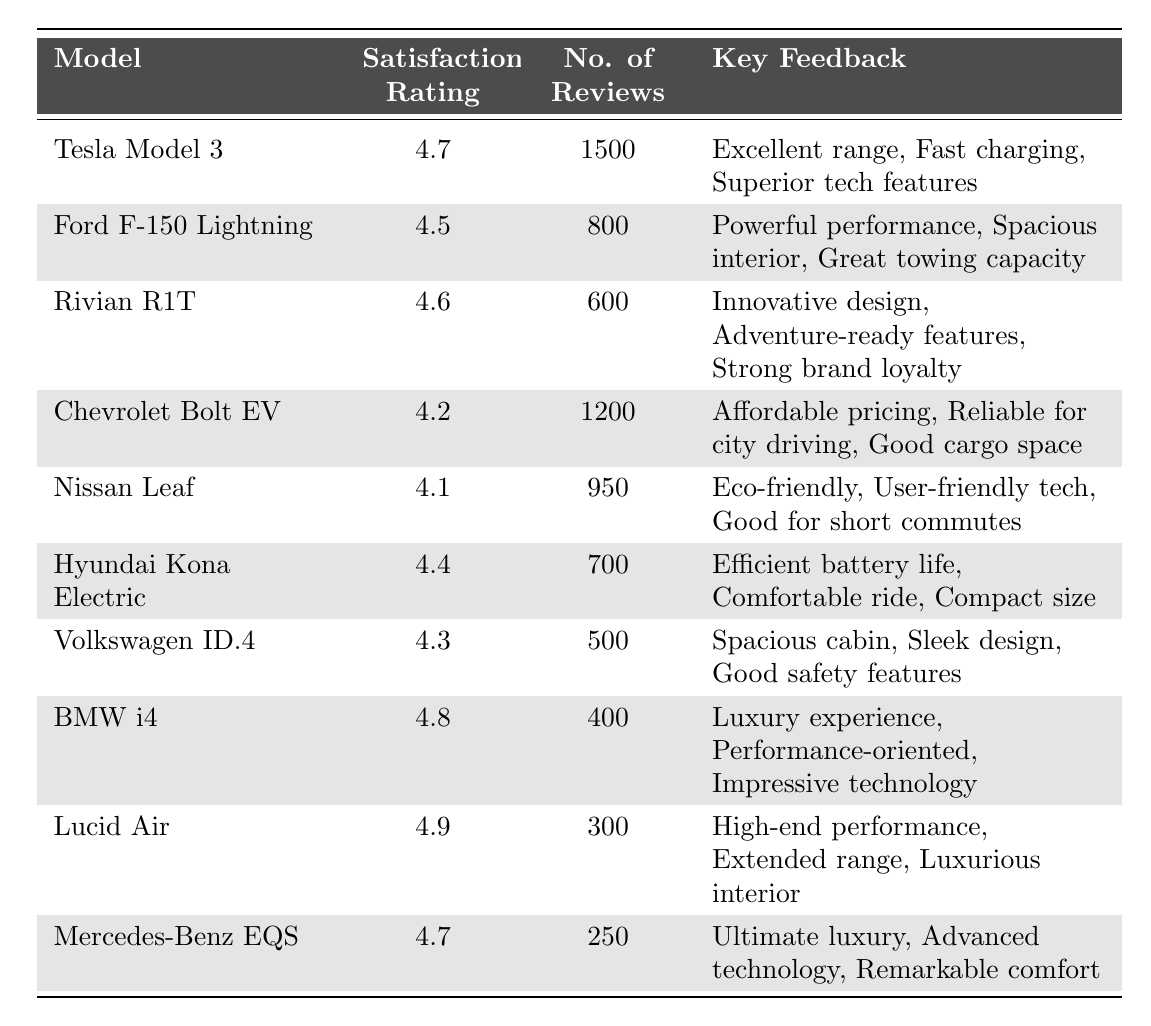What is the highest customer satisfaction rating in the table? The table lists customer satisfaction ratings for various electric vehicle models. By examining the "Satisfaction Rating" column, the highest value is found next to the "Lucid Air," which has a rating of 4.9.
Answer: 4.9 How many reviews did the Chevrolet Bolt EV receive? Referring to the "No. of Reviews" column, the value next to "Chevrolet Bolt EV" is 1200, indicating that it received 1200 reviews.
Answer: 1200 Which electric vehicle model has a customer satisfaction rating of 4.1? The table includes a column for customer satisfaction ratings. The model listed with a rating of 4.1 is the "Nissan Leaf."
Answer: Nissan Leaf What is the average customer satisfaction rating of the vehicles listed? To find the average, first sum all the ratings: (4.7 + 4.5 + 4.6 + 4.2 + 4.1 + 4.4 + 4.3 + 4.8 + 4.9 + 4.7) = 46.2. Then divide by the number of models (10): 46.2 / 10 = 4.62.
Answer: 4.62 How many more reviews does the Tesla Model 3 have compared to the Lucid Air? The Tesla Model 3 has 1500 reviews and the Lucid Air has 300 reviews. To find the difference: 1500 - 300 = 1200.
Answer: 1200 Is the Ford F-150 Lightning rated higher than the Nissan Leaf? The customer satisfaction rating for the Ford F-150 Lightning is 4.5, while the Nissan Leaf is rated at 4.1. Since 4.5 is greater than 4.1, the statement is true.
Answer: Yes Which vehicle model received the fewest reviews? Inspecting the "No. of Reviews" column reveals that the "Lucid Air" has the lowest number of reviews at 300, compared to other models.
Answer: Lucid Air Which two models have the closest customer satisfaction ratings? If we examine the ratings, the "Hyundai Kona Electric" at 4.4 and the "Volkswagen ID.4" at 4.3 are the closest to each other, differing by only 0.1.
Answer: Hyundai Kona Electric and Volkswagen ID.4 What feedback was given for the BMW i4? The "Key Feedback" column for the BMW i4 includes three points: "Luxury experience," "Performance-oriented," and "Impressive technology."
Answer: Luxury experience, Performance-oriented, Impressive technology How many models have a satisfaction rating of 4.5 or higher? To find this, we can count the ratings that are 4.5 or above: Tesla Model 3 (4.7), Ford F-150 Lightning (4.5), Rivian R1T (4.6), BMW i4 (4.8), Lucid Air (4.9), and Mercedes-Benz EQS (4.7). This totals 6 models.
Answer: 6 